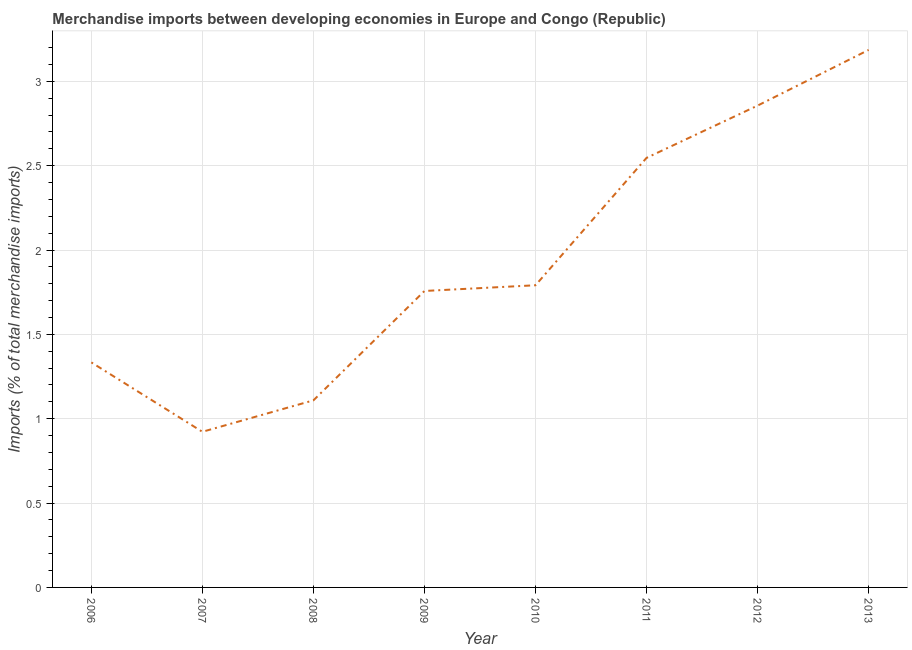What is the merchandise imports in 2011?
Your answer should be compact. 2.55. Across all years, what is the maximum merchandise imports?
Provide a succinct answer. 3.19. Across all years, what is the minimum merchandise imports?
Make the answer very short. 0.92. In which year was the merchandise imports maximum?
Provide a succinct answer. 2013. What is the sum of the merchandise imports?
Make the answer very short. 15.5. What is the difference between the merchandise imports in 2010 and 2013?
Your response must be concise. -1.39. What is the average merchandise imports per year?
Keep it short and to the point. 1.94. What is the median merchandise imports?
Offer a terse response. 1.77. What is the ratio of the merchandise imports in 2006 to that in 2007?
Provide a short and direct response. 1.45. Is the merchandise imports in 2007 less than that in 2009?
Provide a succinct answer. Yes. Is the difference between the merchandise imports in 2006 and 2010 greater than the difference between any two years?
Your response must be concise. No. What is the difference between the highest and the second highest merchandise imports?
Your answer should be very brief. 0.33. Is the sum of the merchandise imports in 2010 and 2013 greater than the maximum merchandise imports across all years?
Keep it short and to the point. Yes. What is the difference between the highest and the lowest merchandise imports?
Your answer should be compact. 2.26. How many years are there in the graph?
Make the answer very short. 8. Are the values on the major ticks of Y-axis written in scientific E-notation?
Give a very brief answer. No. Does the graph contain grids?
Make the answer very short. Yes. What is the title of the graph?
Offer a very short reply. Merchandise imports between developing economies in Europe and Congo (Republic). What is the label or title of the Y-axis?
Your answer should be compact. Imports (% of total merchandise imports). What is the Imports (% of total merchandise imports) in 2006?
Your response must be concise. 1.33. What is the Imports (% of total merchandise imports) in 2007?
Provide a succinct answer. 0.92. What is the Imports (% of total merchandise imports) in 2008?
Your response must be concise. 1.11. What is the Imports (% of total merchandise imports) in 2009?
Your response must be concise. 1.76. What is the Imports (% of total merchandise imports) in 2010?
Provide a succinct answer. 1.79. What is the Imports (% of total merchandise imports) in 2011?
Your response must be concise. 2.55. What is the Imports (% of total merchandise imports) in 2012?
Make the answer very short. 2.86. What is the Imports (% of total merchandise imports) of 2013?
Your answer should be compact. 3.19. What is the difference between the Imports (% of total merchandise imports) in 2006 and 2007?
Provide a succinct answer. 0.41. What is the difference between the Imports (% of total merchandise imports) in 2006 and 2008?
Provide a succinct answer. 0.22. What is the difference between the Imports (% of total merchandise imports) in 2006 and 2009?
Make the answer very short. -0.42. What is the difference between the Imports (% of total merchandise imports) in 2006 and 2010?
Your answer should be compact. -0.46. What is the difference between the Imports (% of total merchandise imports) in 2006 and 2011?
Offer a terse response. -1.21. What is the difference between the Imports (% of total merchandise imports) in 2006 and 2012?
Make the answer very short. -1.52. What is the difference between the Imports (% of total merchandise imports) in 2006 and 2013?
Ensure brevity in your answer.  -1.85. What is the difference between the Imports (% of total merchandise imports) in 2007 and 2008?
Offer a very short reply. -0.19. What is the difference between the Imports (% of total merchandise imports) in 2007 and 2009?
Make the answer very short. -0.83. What is the difference between the Imports (% of total merchandise imports) in 2007 and 2010?
Your response must be concise. -0.87. What is the difference between the Imports (% of total merchandise imports) in 2007 and 2011?
Provide a short and direct response. -1.62. What is the difference between the Imports (% of total merchandise imports) in 2007 and 2012?
Keep it short and to the point. -1.93. What is the difference between the Imports (% of total merchandise imports) in 2007 and 2013?
Ensure brevity in your answer.  -2.26. What is the difference between the Imports (% of total merchandise imports) in 2008 and 2009?
Make the answer very short. -0.65. What is the difference between the Imports (% of total merchandise imports) in 2008 and 2010?
Your response must be concise. -0.68. What is the difference between the Imports (% of total merchandise imports) in 2008 and 2011?
Keep it short and to the point. -1.44. What is the difference between the Imports (% of total merchandise imports) in 2008 and 2012?
Provide a short and direct response. -1.75. What is the difference between the Imports (% of total merchandise imports) in 2008 and 2013?
Offer a terse response. -2.08. What is the difference between the Imports (% of total merchandise imports) in 2009 and 2010?
Keep it short and to the point. -0.03. What is the difference between the Imports (% of total merchandise imports) in 2009 and 2011?
Provide a succinct answer. -0.79. What is the difference between the Imports (% of total merchandise imports) in 2009 and 2012?
Your response must be concise. -1.1. What is the difference between the Imports (% of total merchandise imports) in 2009 and 2013?
Make the answer very short. -1.43. What is the difference between the Imports (% of total merchandise imports) in 2010 and 2011?
Provide a short and direct response. -0.76. What is the difference between the Imports (% of total merchandise imports) in 2010 and 2012?
Keep it short and to the point. -1.06. What is the difference between the Imports (% of total merchandise imports) in 2010 and 2013?
Keep it short and to the point. -1.39. What is the difference between the Imports (% of total merchandise imports) in 2011 and 2012?
Provide a short and direct response. -0.31. What is the difference between the Imports (% of total merchandise imports) in 2011 and 2013?
Give a very brief answer. -0.64. What is the difference between the Imports (% of total merchandise imports) in 2012 and 2013?
Keep it short and to the point. -0.33. What is the ratio of the Imports (% of total merchandise imports) in 2006 to that in 2007?
Provide a succinct answer. 1.45. What is the ratio of the Imports (% of total merchandise imports) in 2006 to that in 2008?
Make the answer very short. 1.2. What is the ratio of the Imports (% of total merchandise imports) in 2006 to that in 2009?
Offer a terse response. 0.76. What is the ratio of the Imports (% of total merchandise imports) in 2006 to that in 2010?
Ensure brevity in your answer.  0.74. What is the ratio of the Imports (% of total merchandise imports) in 2006 to that in 2011?
Your answer should be compact. 0.52. What is the ratio of the Imports (% of total merchandise imports) in 2006 to that in 2012?
Ensure brevity in your answer.  0.47. What is the ratio of the Imports (% of total merchandise imports) in 2006 to that in 2013?
Your answer should be compact. 0.42. What is the ratio of the Imports (% of total merchandise imports) in 2007 to that in 2008?
Offer a very short reply. 0.83. What is the ratio of the Imports (% of total merchandise imports) in 2007 to that in 2009?
Make the answer very short. 0.53. What is the ratio of the Imports (% of total merchandise imports) in 2007 to that in 2010?
Your answer should be very brief. 0.52. What is the ratio of the Imports (% of total merchandise imports) in 2007 to that in 2011?
Your response must be concise. 0.36. What is the ratio of the Imports (% of total merchandise imports) in 2007 to that in 2012?
Keep it short and to the point. 0.32. What is the ratio of the Imports (% of total merchandise imports) in 2007 to that in 2013?
Provide a short and direct response. 0.29. What is the ratio of the Imports (% of total merchandise imports) in 2008 to that in 2009?
Give a very brief answer. 0.63. What is the ratio of the Imports (% of total merchandise imports) in 2008 to that in 2010?
Your answer should be very brief. 0.62. What is the ratio of the Imports (% of total merchandise imports) in 2008 to that in 2011?
Ensure brevity in your answer.  0.44. What is the ratio of the Imports (% of total merchandise imports) in 2008 to that in 2012?
Ensure brevity in your answer.  0.39. What is the ratio of the Imports (% of total merchandise imports) in 2008 to that in 2013?
Your response must be concise. 0.35. What is the ratio of the Imports (% of total merchandise imports) in 2009 to that in 2010?
Make the answer very short. 0.98. What is the ratio of the Imports (% of total merchandise imports) in 2009 to that in 2011?
Keep it short and to the point. 0.69. What is the ratio of the Imports (% of total merchandise imports) in 2009 to that in 2012?
Your response must be concise. 0.61. What is the ratio of the Imports (% of total merchandise imports) in 2009 to that in 2013?
Your response must be concise. 0.55. What is the ratio of the Imports (% of total merchandise imports) in 2010 to that in 2011?
Offer a terse response. 0.7. What is the ratio of the Imports (% of total merchandise imports) in 2010 to that in 2012?
Your response must be concise. 0.63. What is the ratio of the Imports (% of total merchandise imports) in 2010 to that in 2013?
Keep it short and to the point. 0.56. What is the ratio of the Imports (% of total merchandise imports) in 2011 to that in 2012?
Your answer should be compact. 0.89. What is the ratio of the Imports (% of total merchandise imports) in 2011 to that in 2013?
Provide a succinct answer. 0.8. What is the ratio of the Imports (% of total merchandise imports) in 2012 to that in 2013?
Provide a short and direct response. 0.9. 